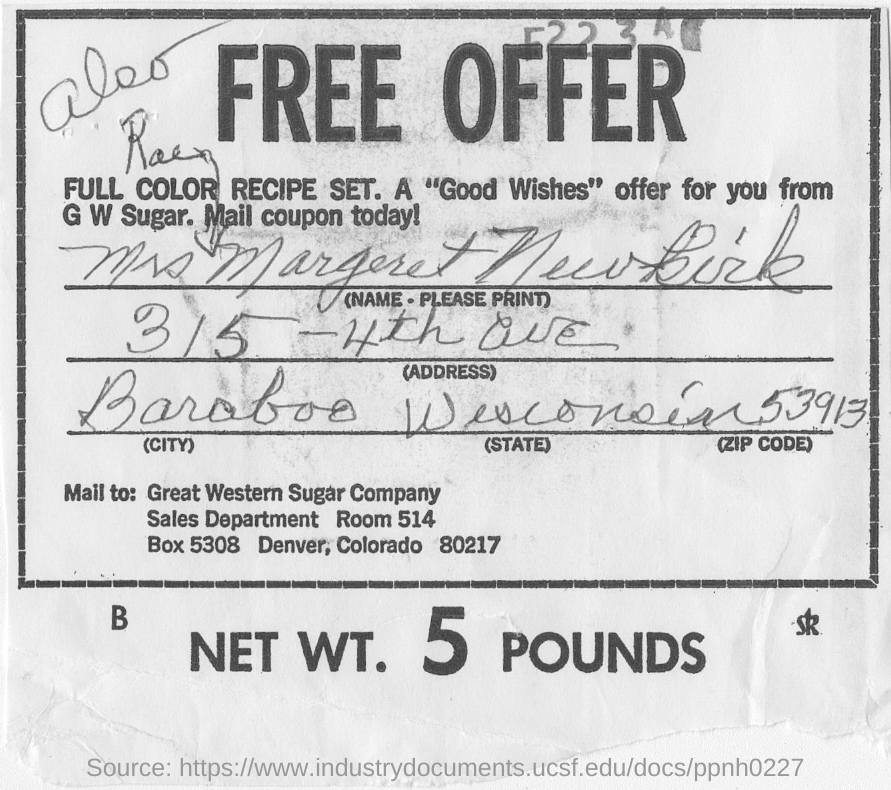Can you tell me more about the company listed on this coupon? The coupon is for the Great Western Sugar Company, which was historically known for producing and selling sugar. They have put out an offer for a full-color recipe set as part of a promotion likely intended to encourage the use of their sugar products in cooking and baking. 